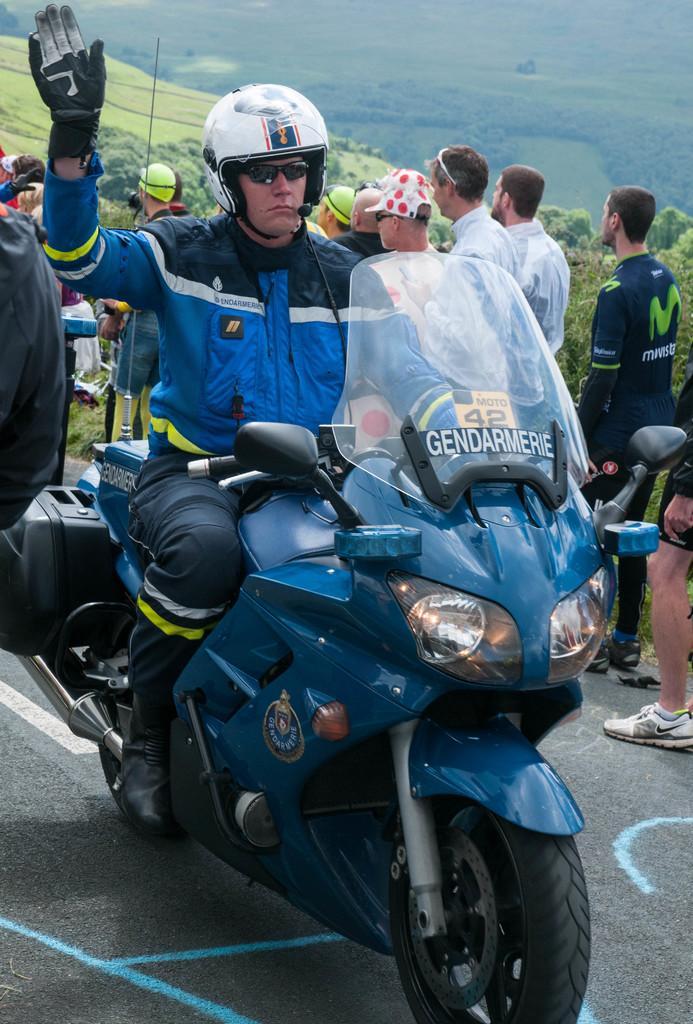Please provide a concise description of this image. Here we see a man riding a motorcycle and we see few people on his side and few trees around. 